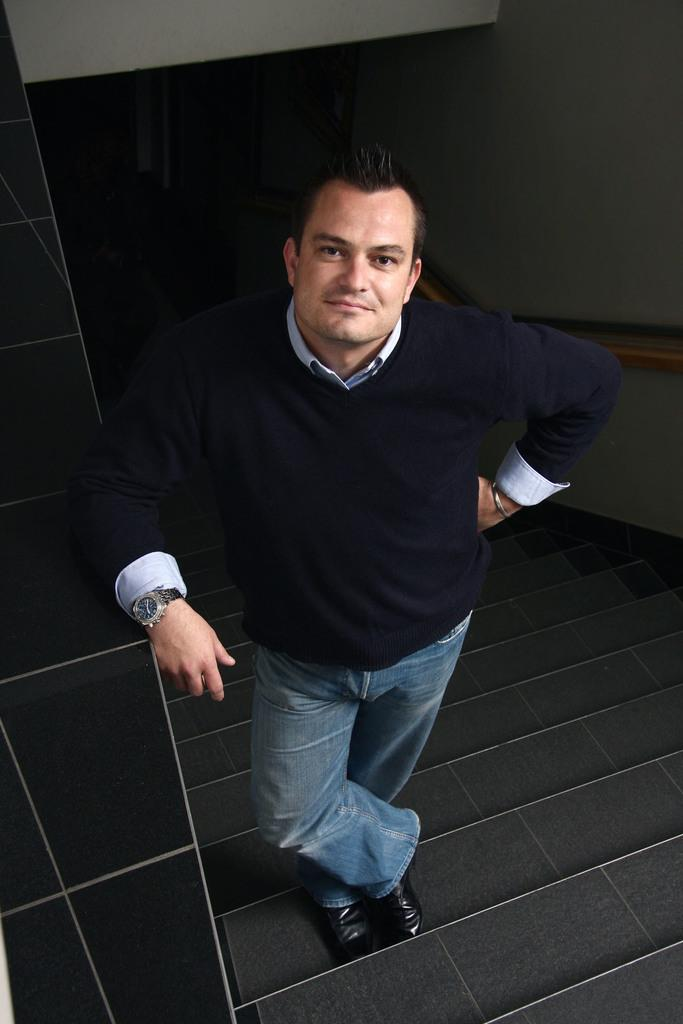What is the main subject of the image? The main subject of the image is a man. What is the man doing in the image? The man is standing on steps in the image. What can be seen on the man's wrist? The man is wearing a watch in the image. What type of clothing is the man wearing on his upper body? The man is wearing a shirt in the image. What type of clothing is the man wearing on his lower body? The man is wearing jeans in the image. What type of footwear is the man wearing? The man is wearing shoes in the image. What is visible in the background of the image? There is a wall and other objects in the background of the image. How many trucks can be seen in the image? There are no trucks present in the image. What color are the man's toes in the image? The man's toes are not visible in the image, so we cannot determine their color. 